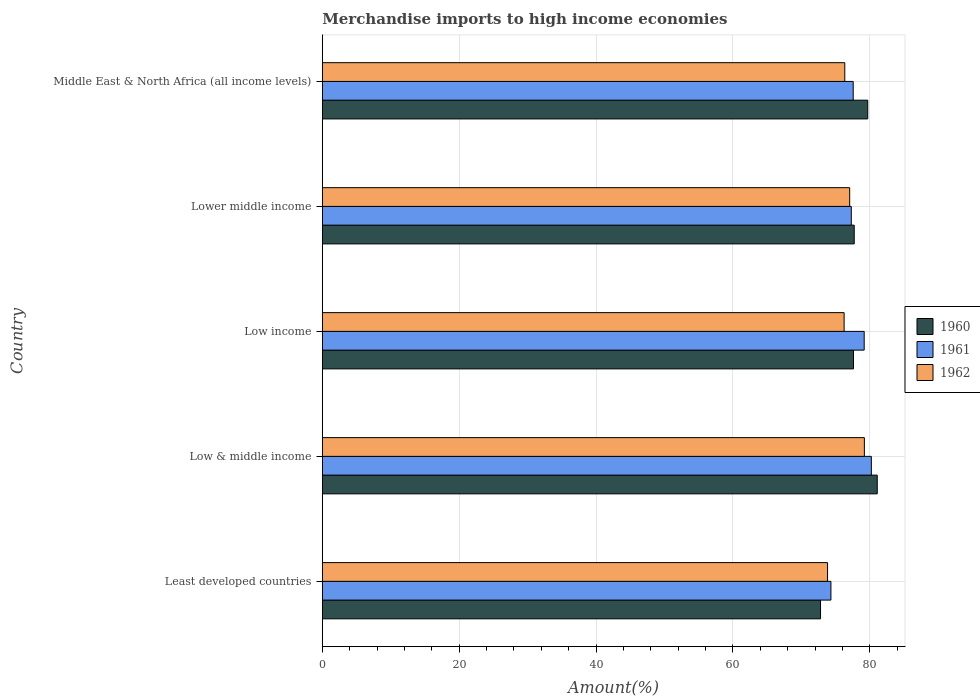How many groups of bars are there?
Offer a terse response. 5. Are the number of bars per tick equal to the number of legend labels?
Your answer should be compact. Yes. How many bars are there on the 5th tick from the top?
Your answer should be very brief. 3. How many bars are there on the 3rd tick from the bottom?
Provide a short and direct response. 3. What is the label of the 3rd group of bars from the top?
Your answer should be compact. Low income. In how many cases, is the number of bars for a given country not equal to the number of legend labels?
Your answer should be compact. 0. What is the percentage of amount earned from merchandise imports in 1960 in Middle East & North Africa (all income levels)?
Provide a short and direct response. 79.7. Across all countries, what is the maximum percentage of amount earned from merchandise imports in 1962?
Your answer should be compact. 79.21. Across all countries, what is the minimum percentage of amount earned from merchandise imports in 1960?
Your response must be concise. 72.8. In which country was the percentage of amount earned from merchandise imports in 1961 minimum?
Provide a short and direct response. Least developed countries. What is the total percentage of amount earned from merchandise imports in 1962 in the graph?
Offer a terse response. 382.7. What is the difference between the percentage of amount earned from merchandise imports in 1960 in Low & middle income and that in Low income?
Your answer should be compact. 3.47. What is the difference between the percentage of amount earned from merchandise imports in 1962 in Lower middle income and the percentage of amount earned from merchandise imports in 1960 in Low & middle income?
Your answer should be very brief. -4.03. What is the average percentage of amount earned from merchandise imports in 1960 per country?
Your answer should be compact. 77.79. What is the difference between the percentage of amount earned from merchandise imports in 1962 and percentage of amount earned from merchandise imports in 1961 in Least developed countries?
Provide a short and direct response. -0.49. What is the ratio of the percentage of amount earned from merchandise imports in 1962 in Low income to that in Lower middle income?
Your response must be concise. 0.99. Is the percentage of amount earned from merchandise imports in 1961 in Low & middle income less than that in Lower middle income?
Ensure brevity in your answer.  No. Is the difference between the percentage of amount earned from merchandise imports in 1962 in Low & middle income and Lower middle income greater than the difference between the percentage of amount earned from merchandise imports in 1961 in Low & middle income and Lower middle income?
Offer a terse response. No. What is the difference between the highest and the second highest percentage of amount earned from merchandise imports in 1960?
Your answer should be very brief. 1.39. What is the difference between the highest and the lowest percentage of amount earned from merchandise imports in 1962?
Make the answer very short. 5.38. In how many countries, is the percentage of amount earned from merchandise imports in 1961 greater than the average percentage of amount earned from merchandise imports in 1961 taken over all countries?
Provide a short and direct response. 2. Is the sum of the percentage of amount earned from merchandise imports in 1961 in Least developed countries and Low & middle income greater than the maximum percentage of amount earned from merchandise imports in 1962 across all countries?
Your answer should be compact. Yes. What does the 1st bar from the top in Least developed countries represents?
Your response must be concise. 1962. What does the 1st bar from the bottom in Low income represents?
Give a very brief answer. 1960. Are all the bars in the graph horizontal?
Give a very brief answer. Yes. How many countries are there in the graph?
Make the answer very short. 5. Are the values on the major ticks of X-axis written in scientific E-notation?
Provide a succinct answer. No. Does the graph contain any zero values?
Make the answer very short. No. Does the graph contain grids?
Provide a succinct answer. Yes. Where does the legend appear in the graph?
Provide a succinct answer. Center right. What is the title of the graph?
Keep it short and to the point. Merchandise imports to high income economies. What is the label or title of the X-axis?
Your answer should be very brief. Amount(%). What is the Amount(%) of 1960 in Least developed countries?
Keep it short and to the point. 72.8. What is the Amount(%) of 1961 in Least developed countries?
Your answer should be compact. 74.32. What is the Amount(%) of 1962 in Least developed countries?
Your answer should be compact. 73.83. What is the Amount(%) of 1960 in Low & middle income?
Offer a terse response. 81.09. What is the Amount(%) in 1961 in Low & middle income?
Keep it short and to the point. 80.23. What is the Amount(%) in 1962 in Low & middle income?
Your answer should be very brief. 79.21. What is the Amount(%) of 1960 in Low income?
Provide a succinct answer. 77.62. What is the Amount(%) of 1961 in Low income?
Provide a short and direct response. 79.18. What is the Amount(%) of 1962 in Low income?
Give a very brief answer. 76.25. What is the Amount(%) of 1960 in Lower middle income?
Make the answer very short. 77.73. What is the Amount(%) in 1961 in Lower middle income?
Your answer should be compact. 77.3. What is the Amount(%) in 1962 in Lower middle income?
Your response must be concise. 77.06. What is the Amount(%) of 1960 in Middle East & North Africa (all income levels)?
Offer a very short reply. 79.7. What is the Amount(%) in 1961 in Middle East & North Africa (all income levels)?
Provide a short and direct response. 77.58. What is the Amount(%) of 1962 in Middle East & North Africa (all income levels)?
Provide a short and direct response. 76.35. Across all countries, what is the maximum Amount(%) of 1960?
Offer a very short reply. 81.09. Across all countries, what is the maximum Amount(%) of 1961?
Your answer should be very brief. 80.23. Across all countries, what is the maximum Amount(%) of 1962?
Keep it short and to the point. 79.21. Across all countries, what is the minimum Amount(%) in 1960?
Provide a short and direct response. 72.8. Across all countries, what is the minimum Amount(%) in 1961?
Provide a short and direct response. 74.32. Across all countries, what is the minimum Amount(%) in 1962?
Keep it short and to the point. 73.83. What is the total Amount(%) in 1960 in the graph?
Your answer should be compact. 388.94. What is the total Amount(%) of 1961 in the graph?
Your answer should be compact. 388.61. What is the total Amount(%) in 1962 in the graph?
Your answer should be compact. 382.7. What is the difference between the Amount(%) of 1960 in Least developed countries and that in Low & middle income?
Make the answer very short. -8.29. What is the difference between the Amount(%) of 1961 in Least developed countries and that in Low & middle income?
Your answer should be compact. -5.91. What is the difference between the Amount(%) of 1962 in Least developed countries and that in Low & middle income?
Make the answer very short. -5.38. What is the difference between the Amount(%) in 1960 in Least developed countries and that in Low income?
Provide a succinct answer. -4.81. What is the difference between the Amount(%) in 1961 in Least developed countries and that in Low income?
Give a very brief answer. -4.86. What is the difference between the Amount(%) of 1962 in Least developed countries and that in Low income?
Keep it short and to the point. -2.42. What is the difference between the Amount(%) of 1960 in Least developed countries and that in Lower middle income?
Make the answer very short. -4.92. What is the difference between the Amount(%) of 1961 in Least developed countries and that in Lower middle income?
Your answer should be very brief. -2.98. What is the difference between the Amount(%) in 1962 in Least developed countries and that in Lower middle income?
Your answer should be very brief. -3.24. What is the difference between the Amount(%) in 1960 in Least developed countries and that in Middle East & North Africa (all income levels)?
Keep it short and to the point. -6.9. What is the difference between the Amount(%) in 1961 in Least developed countries and that in Middle East & North Africa (all income levels)?
Your answer should be compact. -3.26. What is the difference between the Amount(%) of 1962 in Least developed countries and that in Middle East & North Africa (all income levels)?
Offer a terse response. -2.52. What is the difference between the Amount(%) in 1960 in Low & middle income and that in Low income?
Your response must be concise. 3.47. What is the difference between the Amount(%) of 1961 in Low & middle income and that in Low income?
Give a very brief answer. 1.05. What is the difference between the Amount(%) of 1962 in Low & middle income and that in Low income?
Provide a succinct answer. 2.96. What is the difference between the Amount(%) of 1960 in Low & middle income and that in Lower middle income?
Give a very brief answer. 3.36. What is the difference between the Amount(%) in 1961 in Low & middle income and that in Lower middle income?
Offer a very short reply. 2.93. What is the difference between the Amount(%) of 1962 in Low & middle income and that in Lower middle income?
Give a very brief answer. 2.15. What is the difference between the Amount(%) in 1960 in Low & middle income and that in Middle East & North Africa (all income levels)?
Your response must be concise. 1.39. What is the difference between the Amount(%) in 1961 in Low & middle income and that in Middle East & North Africa (all income levels)?
Ensure brevity in your answer.  2.65. What is the difference between the Amount(%) in 1962 in Low & middle income and that in Middle East & North Africa (all income levels)?
Give a very brief answer. 2.86. What is the difference between the Amount(%) of 1960 in Low income and that in Lower middle income?
Offer a terse response. -0.11. What is the difference between the Amount(%) in 1961 in Low income and that in Lower middle income?
Make the answer very short. 1.88. What is the difference between the Amount(%) of 1962 in Low income and that in Lower middle income?
Provide a short and direct response. -0.81. What is the difference between the Amount(%) in 1960 in Low income and that in Middle East & North Africa (all income levels)?
Provide a succinct answer. -2.09. What is the difference between the Amount(%) in 1961 in Low income and that in Middle East & North Africa (all income levels)?
Provide a succinct answer. 1.6. What is the difference between the Amount(%) of 1962 in Low income and that in Middle East & North Africa (all income levels)?
Your answer should be very brief. -0.1. What is the difference between the Amount(%) of 1960 in Lower middle income and that in Middle East & North Africa (all income levels)?
Offer a terse response. -1.98. What is the difference between the Amount(%) of 1961 in Lower middle income and that in Middle East & North Africa (all income levels)?
Make the answer very short. -0.28. What is the difference between the Amount(%) in 1962 in Lower middle income and that in Middle East & North Africa (all income levels)?
Provide a short and direct response. 0.72. What is the difference between the Amount(%) in 1960 in Least developed countries and the Amount(%) in 1961 in Low & middle income?
Ensure brevity in your answer.  -7.43. What is the difference between the Amount(%) of 1960 in Least developed countries and the Amount(%) of 1962 in Low & middle income?
Your answer should be very brief. -6.41. What is the difference between the Amount(%) in 1961 in Least developed countries and the Amount(%) in 1962 in Low & middle income?
Your answer should be very brief. -4.89. What is the difference between the Amount(%) in 1960 in Least developed countries and the Amount(%) in 1961 in Low income?
Offer a very short reply. -6.38. What is the difference between the Amount(%) of 1960 in Least developed countries and the Amount(%) of 1962 in Low income?
Your answer should be compact. -3.45. What is the difference between the Amount(%) of 1961 in Least developed countries and the Amount(%) of 1962 in Low income?
Keep it short and to the point. -1.93. What is the difference between the Amount(%) of 1960 in Least developed countries and the Amount(%) of 1961 in Lower middle income?
Offer a terse response. -4.49. What is the difference between the Amount(%) of 1960 in Least developed countries and the Amount(%) of 1962 in Lower middle income?
Make the answer very short. -4.26. What is the difference between the Amount(%) of 1961 in Least developed countries and the Amount(%) of 1962 in Lower middle income?
Offer a terse response. -2.74. What is the difference between the Amount(%) in 1960 in Least developed countries and the Amount(%) in 1961 in Middle East & North Africa (all income levels)?
Give a very brief answer. -4.77. What is the difference between the Amount(%) in 1960 in Least developed countries and the Amount(%) in 1962 in Middle East & North Africa (all income levels)?
Make the answer very short. -3.54. What is the difference between the Amount(%) in 1961 in Least developed countries and the Amount(%) in 1962 in Middle East & North Africa (all income levels)?
Your response must be concise. -2.03. What is the difference between the Amount(%) in 1960 in Low & middle income and the Amount(%) in 1961 in Low income?
Your response must be concise. 1.91. What is the difference between the Amount(%) of 1960 in Low & middle income and the Amount(%) of 1962 in Low income?
Make the answer very short. 4.84. What is the difference between the Amount(%) in 1961 in Low & middle income and the Amount(%) in 1962 in Low income?
Provide a short and direct response. 3.98. What is the difference between the Amount(%) of 1960 in Low & middle income and the Amount(%) of 1961 in Lower middle income?
Your answer should be very brief. 3.79. What is the difference between the Amount(%) of 1960 in Low & middle income and the Amount(%) of 1962 in Lower middle income?
Your answer should be compact. 4.03. What is the difference between the Amount(%) of 1961 in Low & middle income and the Amount(%) of 1962 in Lower middle income?
Provide a short and direct response. 3.17. What is the difference between the Amount(%) in 1960 in Low & middle income and the Amount(%) in 1961 in Middle East & North Africa (all income levels)?
Your response must be concise. 3.51. What is the difference between the Amount(%) of 1960 in Low & middle income and the Amount(%) of 1962 in Middle East & North Africa (all income levels)?
Offer a terse response. 4.74. What is the difference between the Amount(%) of 1961 in Low & middle income and the Amount(%) of 1962 in Middle East & North Africa (all income levels)?
Offer a very short reply. 3.88. What is the difference between the Amount(%) of 1960 in Low income and the Amount(%) of 1961 in Lower middle income?
Make the answer very short. 0.32. What is the difference between the Amount(%) in 1960 in Low income and the Amount(%) in 1962 in Lower middle income?
Offer a very short reply. 0.55. What is the difference between the Amount(%) in 1961 in Low income and the Amount(%) in 1962 in Lower middle income?
Make the answer very short. 2.12. What is the difference between the Amount(%) of 1960 in Low income and the Amount(%) of 1961 in Middle East & North Africa (all income levels)?
Your answer should be very brief. 0.04. What is the difference between the Amount(%) of 1960 in Low income and the Amount(%) of 1962 in Middle East & North Africa (all income levels)?
Provide a succinct answer. 1.27. What is the difference between the Amount(%) of 1961 in Low income and the Amount(%) of 1962 in Middle East & North Africa (all income levels)?
Offer a terse response. 2.84. What is the difference between the Amount(%) of 1960 in Lower middle income and the Amount(%) of 1961 in Middle East & North Africa (all income levels)?
Your response must be concise. 0.15. What is the difference between the Amount(%) in 1960 in Lower middle income and the Amount(%) in 1962 in Middle East & North Africa (all income levels)?
Your response must be concise. 1.38. What is the difference between the Amount(%) in 1961 in Lower middle income and the Amount(%) in 1962 in Middle East & North Africa (all income levels)?
Provide a succinct answer. 0.95. What is the average Amount(%) in 1960 per country?
Offer a terse response. 77.79. What is the average Amount(%) of 1961 per country?
Offer a terse response. 77.72. What is the average Amount(%) of 1962 per country?
Provide a short and direct response. 76.54. What is the difference between the Amount(%) in 1960 and Amount(%) in 1961 in Least developed countries?
Make the answer very short. -1.52. What is the difference between the Amount(%) in 1960 and Amount(%) in 1962 in Least developed countries?
Provide a succinct answer. -1.02. What is the difference between the Amount(%) of 1961 and Amount(%) of 1962 in Least developed countries?
Ensure brevity in your answer.  0.49. What is the difference between the Amount(%) of 1960 and Amount(%) of 1961 in Low & middle income?
Provide a short and direct response. 0.86. What is the difference between the Amount(%) of 1960 and Amount(%) of 1962 in Low & middle income?
Make the answer very short. 1.88. What is the difference between the Amount(%) of 1961 and Amount(%) of 1962 in Low & middle income?
Your response must be concise. 1.02. What is the difference between the Amount(%) in 1960 and Amount(%) in 1961 in Low income?
Your answer should be very brief. -1.56. What is the difference between the Amount(%) of 1960 and Amount(%) of 1962 in Low income?
Your answer should be compact. 1.37. What is the difference between the Amount(%) in 1961 and Amount(%) in 1962 in Low income?
Your response must be concise. 2.93. What is the difference between the Amount(%) of 1960 and Amount(%) of 1961 in Lower middle income?
Provide a short and direct response. 0.43. What is the difference between the Amount(%) of 1960 and Amount(%) of 1962 in Lower middle income?
Your answer should be compact. 0.66. What is the difference between the Amount(%) in 1961 and Amount(%) in 1962 in Lower middle income?
Give a very brief answer. 0.24. What is the difference between the Amount(%) of 1960 and Amount(%) of 1961 in Middle East & North Africa (all income levels)?
Keep it short and to the point. 2.13. What is the difference between the Amount(%) of 1960 and Amount(%) of 1962 in Middle East & North Africa (all income levels)?
Offer a very short reply. 3.36. What is the difference between the Amount(%) of 1961 and Amount(%) of 1962 in Middle East & North Africa (all income levels)?
Offer a very short reply. 1.23. What is the ratio of the Amount(%) in 1960 in Least developed countries to that in Low & middle income?
Your answer should be compact. 0.9. What is the ratio of the Amount(%) in 1961 in Least developed countries to that in Low & middle income?
Ensure brevity in your answer.  0.93. What is the ratio of the Amount(%) in 1962 in Least developed countries to that in Low & middle income?
Provide a succinct answer. 0.93. What is the ratio of the Amount(%) of 1960 in Least developed countries to that in Low income?
Your answer should be very brief. 0.94. What is the ratio of the Amount(%) in 1961 in Least developed countries to that in Low income?
Make the answer very short. 0.94. What is the ratio of the Amount(%) in 1962 in Least developed countries to that in Low income?
Your answer should be very brief. 0.97. What is the ratio of the Amount(%) of 1960 in Least developed countries to that in Lower middle income?
Your response must be concise. 0.94. What is the ratio of the Amount(%) of 1961 in Least developed countries to that in Lower middle income?
Your answer should be compact. 0.96. What is the ratio of the Amount(%) of 1962 in Least developed countries to that in Lower middle income?
Your response must be concise. 0.96. What is the ratio of the Amount(%) of 1960 in Least developed countries to that in Middle East & North Africa (all income levels)?
Provide a succinct answer. 0.91. What is the ratio of the Amount(%) of 1961 in Least developed countries to that in Middle East & North Africa (all income levels)?
Provide a short and direct response. 0.96. What is the ratio of the Amount(%) of 1962 in Least developed countries to that in Middle East & North Africa (all income levels)?
Ensure brevity in your answer.  0.97. What is the ratio of the Amount(%) in 1960 in Low & middle income to that in Low income?
Provide a short and direct response. 1.04. What is the ratio of the Amount(%) in 1961 in Low & middle income to that in Low income?
Make the answer very short. 1.01. What is the ratio of the Amount(%) of 1962 in Low & middle income to that in Low income?
Your answer should be compact. 1.04. What is the ratio of the Amount(%) in 1960 in Low & middle income to that in Lower middle income?
Provide a succinct answer. 1.04. What is the ratio of the Amount(%) in 1961 in Low & middle income to that in Lower middle income?
Give a very brief answer. 1.04. What is the ratio of the Amount(%) in 1962 in Low & middle income to that in Lower middle income?
Offer a very short reply. 1.03. What is the ratio of the Amount(%) in 1960 in Low & middle income to that in Middle East & North Africa (all income levels)?
Offer a terse response. 1.02. What is the ratio of the Amount(%) in 1961 in Low & middle income to that in Middle East & North Africa (all income levels)?
Your answer should be very brief. 1.03. What is the ratio of the Amount(%) in 1962 in Low & middle income to that in Middle East & North Africa (all income levels)?
Provide a succinct answer. 1.04. What is the ratio of the Amount(%) of 1960 in Low income to that in Lower middle income?
Offer a very short reply. 1. What is the ratio of the Amount(%) of 1961 in Low income to that in Lower middle income?
Your answer should be compact. 1.02. What is the ratio of the Amount(%) of 1960 in Low income to that in Middle East & North Africa (all income levels)?
Offer a terse response. 0.97. What is the ratio of the Amount(%) of 1961 in Low income to that in Middle East & North Africa (all income levels)?
Make the answer very short. 1.02. What is the ratio of the Amount(%) in 1962 in Low income to that in Middle East & North Africa (all income levels)?
Your answer should be compact. 1. What is the ratio of the Amount(%) of 1960 in Lower middle income to that in Middle East & North Africa (all income levels)?
Your answer should be very brief. 0.98. What is the ratio of the Amount(%) in 1962 in Lower middle income to that in Middle East & North Africa (all income levels)?
Your answer should be very brief. 1.01. What is the difference between the highest and the second highest Amount(%) in 1960?
Your response must be concise. 1.39. What is the difference between the highest and the second highest Amount(%) of 1961?
Provide a short and direct response. 1.05. What is the difference between the highest and the second highest Amount(%) in 1962?
Make the answer very short. 2.15. What is the difference between the highest and the lowest Amount(%) of 1960?
Keep it short and to the point. 8.29. What is the difference between the highest and the lowest Amount(%) in 1961?
Provide a succinct answer. 5.91. What is the difference between the highest and the lowest Amount(%) of 1962?
Offer a very short reply. 5.38. 